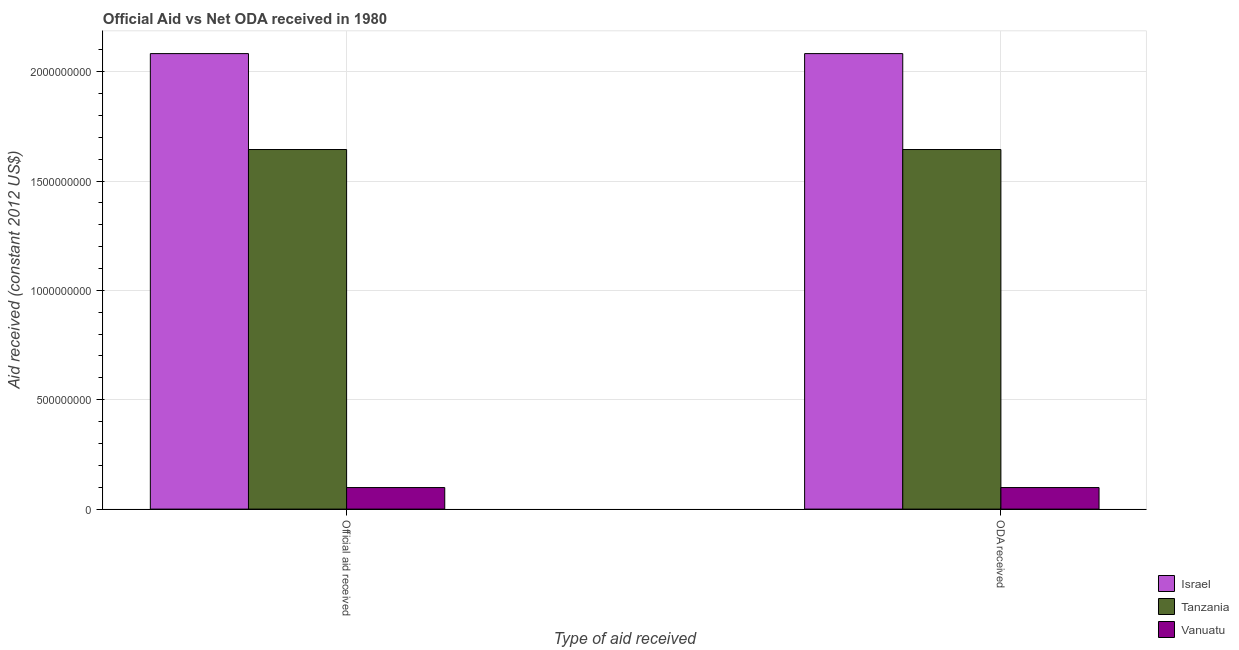How many different coloured bars are there?
Provide a succinct answer. 3. How many groups of bars are there?
Ensure brevity in your answer.  2. Are the number of bars on each tick of the X-axis equal?
Your answer should be compact. Yes. How many bars are there on the 1st tick from the left?
Keep it short and to the point. 3. What is the label of the 2nd group of bars from the left?
Provide a short and direct response. ODA received. What is the official aid received in Tanzania?
Your answer should be compact. 1.64e+09. Across all countries, what is the maximum oda received?
Keep it short and to the point. 2.08e+09. Across all countries, what is the minimum official aid received?
Your answer should be very brief. 9.85e+07. In which country was the official aid received maximum?
Your answer should be compact. Israel. In which country was the official aid received minimum?
Ensure brevity in your answer.  Vanuatu. What is the total oda received in the graph?
Make the answer very short. 3.82e+09. What is the difference between the official aid received in Israel and that in Vanuatu?
Provide a short and direct response. 1.98e+09. What is the difference between the official aid received in Tanzania and the oda received in Israel?
Ensure brevity in your answer.  -4.39e+08. What is the average oda received per country?
Offer a terse response. 1.28e+09. What is the difference between the oda received and official aid received in Tanzania?
Ensure brevity in your answer.  0. What is the ratio of the official aid received in Vanuatu to that in Israel?
Provide a short and direct response. 0.05. Is the oda received in Vanuatu less than that in Tanzania?
Keep it short and to the point. Yes. What does the 2nd bar from the left in Official aid received represents?
Offer a very short reply. Tanzania. What does the 2nd bar from the right in ODA received represents?
Ensure brevity in your answer.  Tanzania. How many countries are there in the graph?
Your response must be concise. 3. Are the values on the major ticks of Y-axis written in scientific E-notation?
Give a very brief answer. No. Where does the legend appear in the graph?
Your answer should be compact. Bottom right. How many legend labels are there?
Provide a short and direct response. 3. What is the title of the graph?
Ensure brevity in your answer.  Official Aid vs Net ODA received in 1980 . Does "Georgia" appear as one of the legend labels in the graph?
Keep it short and to the point. No. What is the label or title of the X-axis?
Provide a short and direct response. Type of aid received. What is the label or title of the Y-axis?
Your answer should be very brief. Aid received (constant 2012 US$). What is the Aid received (constant 2012 US$) in Israel in Official aid received?
Offer a terse response. 2.08e+09. What is the Aid received (constant 2012 US$) of Tanzania in Official aid received?
Ensure brevity in your answer.  1.64e+09. What is the Aid received (constant 2012 US$) in Vanuatu in Official aid received?
Your answer should be compact. 9.85e+07. What is the Aid received (constant 2012 US$) in Israel in ODA received?
Give a very brief answer. 2.08e+09. What is the Aid received (constant 2012 US$) in Tanzania in ODA received?
Provide a succinct answer. 1.64e+09. What is the Aid received (constant 2012 US$) in Vanuatu in ODA received?
Offer a terse response. 9.85e+07. Across all Type of aid received, what is the maximum Aid received (constant 2012 US$) in Israel?
Your answer should be very brief. 2.08e+09. Across all Type of aid received, what is the maximum Aid received (constant 2012 US$) of Tanzania?
Offer a very short reply. 1.64e+09. Across all Type of aid received, what is the maximum Aid received (constant 2012 US$) of Vanuatu?
Ensure brevity in your answer.  9.85e+07. Across all Type of aid received, what is the minimum Aid received (constant 2012 US$) in Israel?
Provide a succinct answer. 2.08e+09. Across all Type of aid received, what is the minimum Aid received (constant 2012 US$) of Tanzania?
Provide a short and direct response. 1.64e+09. Across all Type of aid received, what is the minimum Aid received (constant 2012 US$) of Vanuatu?
Make the answer very short. 9.85e+07. What is the total Aid received (constant 2012 US$) of Israel in the graph?
Provide a short and direct response. 4.17e+09. What is the total Aid received (constant 2012 US$) in Tanzania in the graph?
Your answer should be very brief. 3.29e+09. What is the total Aid received (constant 2012 US$) in Vanuatu in the graph?
Offer a very short reply. 1.97e+08. What is the difference between the Aid received (constant 2012 US$) of Israel in Official aid received and that in ODA received?
Your response must be concise. 0. What is the difference between the Aid received (constant 2012 US$) in Tanzania in Official aid received and that in ODA received?
Offer a terse response. 0. What is the difference between the Aid received (constant 2012 US$) in Israel in Official aid received and the Aid received (constant 2012 US$) in Tanzania in ODA received?
Make the answer very short. 4.39e+08. What is the difference between the Aid received (constant 2012 US$) in Israel in Official aid received and the Aid received (constant 2012 US$) in Vanuatu in ODA received?
Ensure brevity in your answer.  1.98e+09. What is the difference between the Aid received (constant 2012 US$) in Tanzania in Official aid received and the Aid received (constant 2012 US$) in Vanuatu in ODA received?
Keep it short and to the point. 1.55e+09. What is the average Aid received (constant 2012 US$) of Israel per Type of aid received?
Your answer should be very brief. 2.08e+09. What is the average Aid received (constant 2012 US$) of Tanzania per Type of aid received?
Give a very brief answer. 1.64e+09. What is the average Aid received (constant 2012 US$) of Vanuatu per Type of aid received?
Offer a terse response. 9.85e+07. What is the difference between the Aid received (constant 2012 US$) of Israel and Aid received (constant 2012 US$) of Tanzania in Official aid received?
Provide a succinct answer. 4.39e+08. What is the difference between the Aid received (constant 2012 US$) in Israel and Aid received (constant 2012 US$) in Vanuatu in Official aid received?
Provide a succinct answer. 1.98e+09. What is the difference between the Aid received (constant 2012 US$) of Tanzania and Aid received (constant 2012 US$) of Vanuatu in Official aid received?
Ensure brevity in your answer.  1.55e+09. What is the difference between the Aid received (constant 2012 US$) of Israel and Aid received (constant 2012 US$) of Tanzania in ODA received?
Make the answer very short. 4.39e+08. What is the difference between the Aid received (constant 2012 US$) in Israel and Aid received (constant 2012 US$) in Vanuatu in ODA received?
Provide a short and direct response. 1.98e+09. What is the difference between the Aid received (constant 2012 US$) of Tanzania and Aid received (constant 2012 US$) of Vanuatu in ODA received?
Ensure brevity in your answer.  1.55e+09. What is the difference between the highest and the lowest Aid received (constant 2012 US$) of Israel?
Provide a short and direct response. 0. What is the difference between the highest and the lowest Aid received (constant 2012 US$) of Tanzania?
Your answer should be very brief. 0. What is the difference between the highest and the lowest Aid received (constant 2012 US$) in Vanuatu?
Ensure brevity in your answer.  0. 